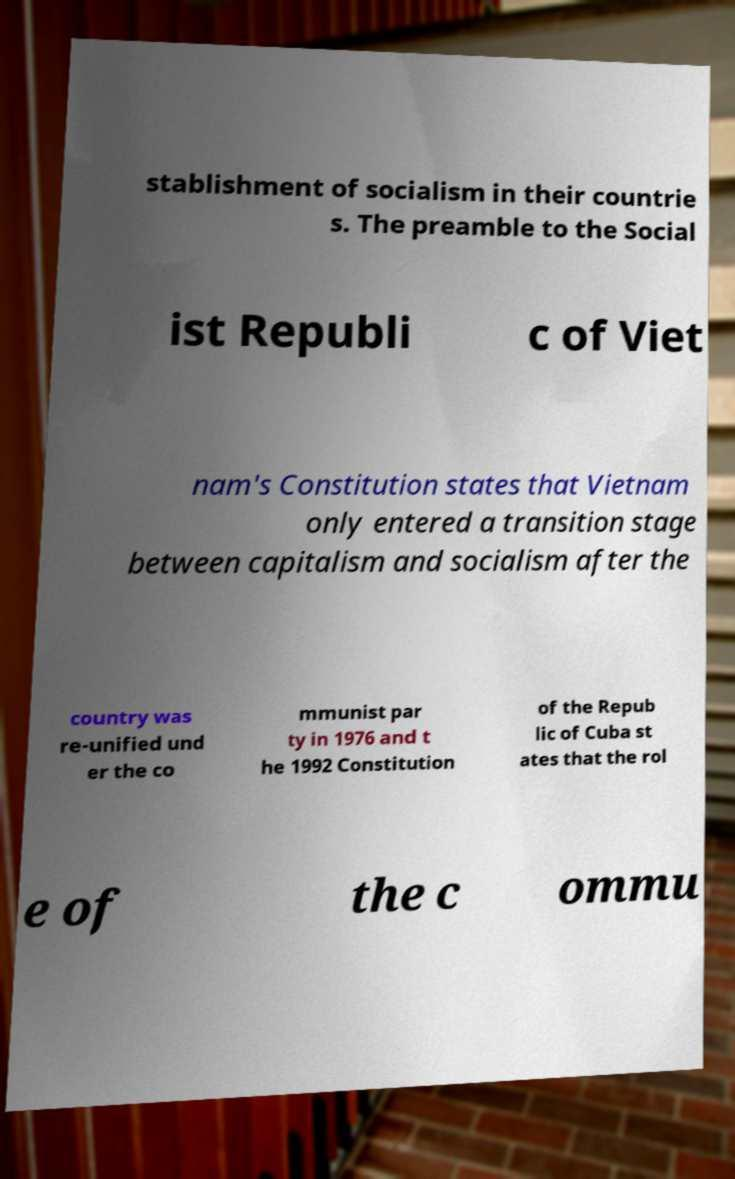Please read and relay the text visible in this image. What does it say? stablishment of socialism in their countrie s. The preamble to the Social ist Republi c of Viet nam's Constitution states that Vietnam only entered a transition stage between capitalism and socialism after the country was re-unified und er the co mmunist par ty in 1976 and t he 1992 Constitution of the Repub lic of Cuba st ates that the rol e of the c ommu 